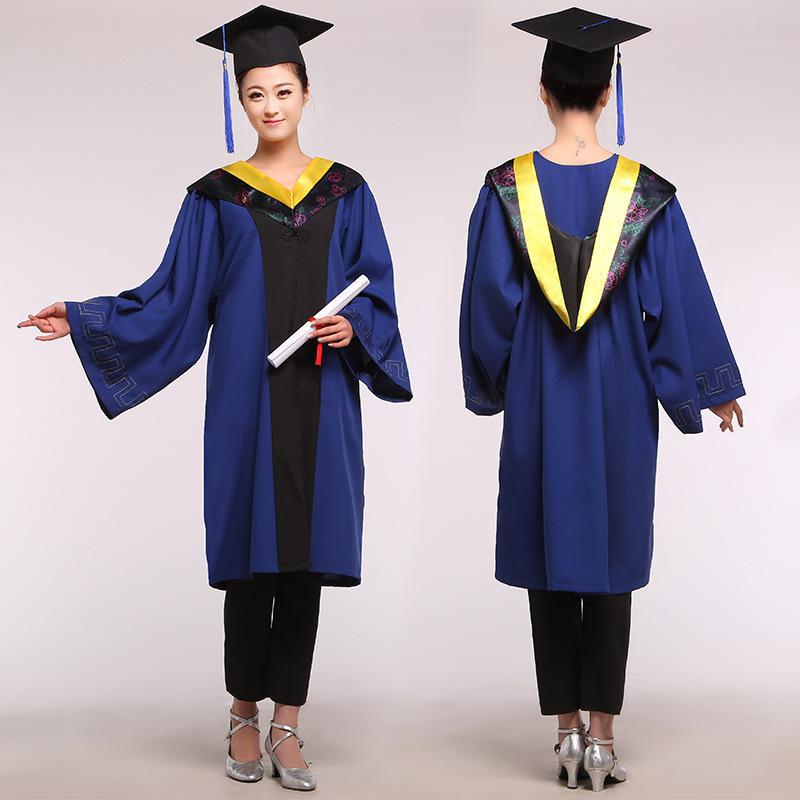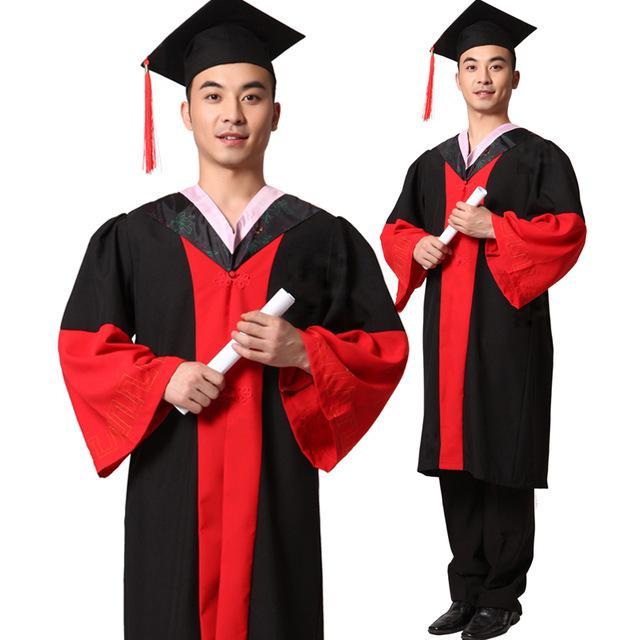The first image is the image on the left, the second image is the image on the right. Considering the images on both sides, is "Someone is carrying a book next to someone who isn't carrying a book." valid? Answer yes or no. No. The first image is the image on the left, the second image is the image on the right. Analyze the images presented: Is the assertion "A student is holding a diploma with her left hand and pointing with her right hand." valid? Answer yes or no. Yes. 